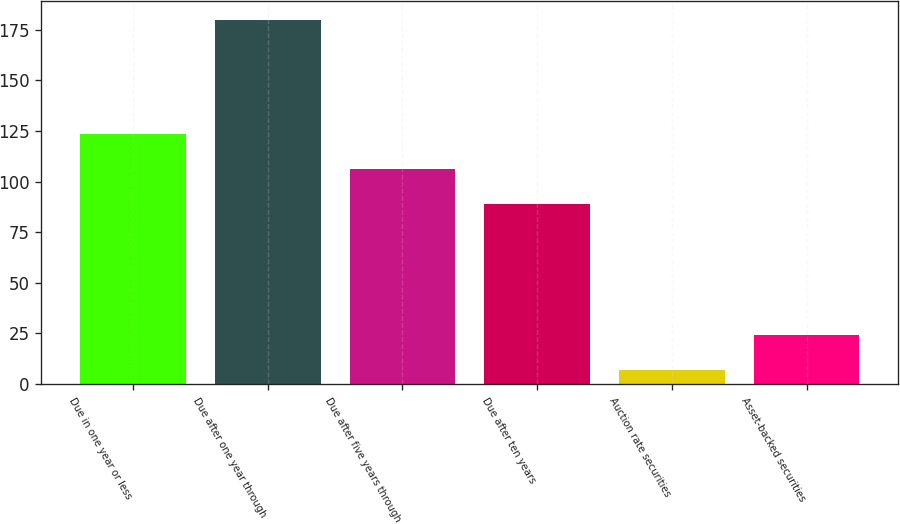<chart> <loc_0><loc_0><loc_500><loc_500><bar_chart><fcel>Due in one year or less<fcel>Due after one year through<fcel>Due after five years through<fcel>Due after ten years<fcel>Auction rate securities<fcel>Asset-backed securities<nl><fcel>123.6<fcel>180<fcel>106.3<fcel>89<fcel>7<fcel>24.3<nl></chart> 